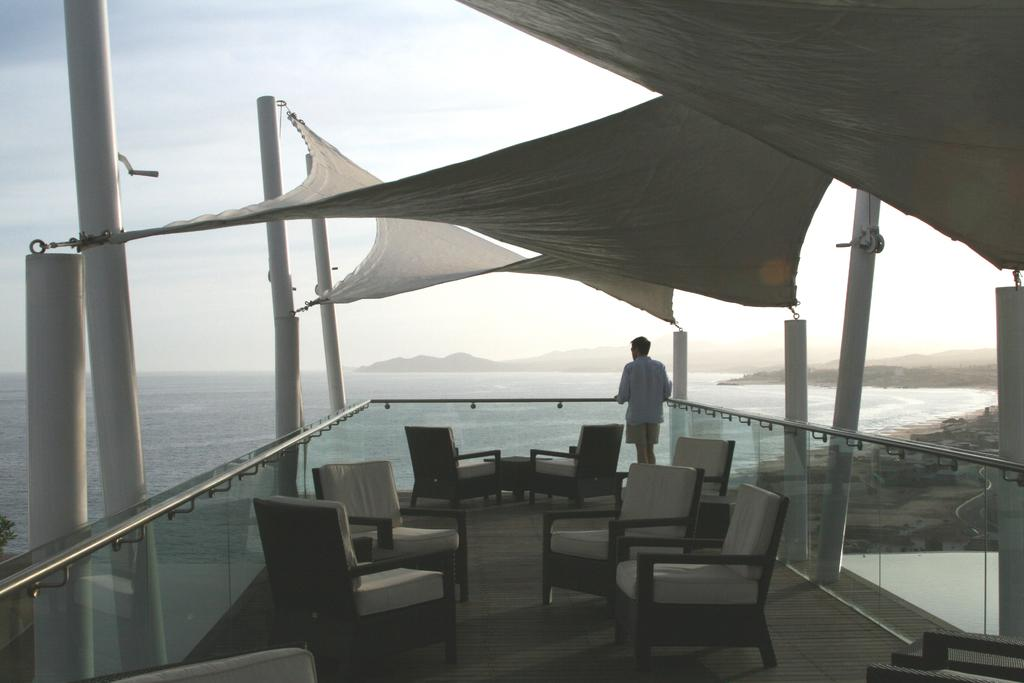What is the main subject of the image? The main subject of the image is a boat visible on a lake. What can be found inside the boat? The boat has chairs in it. What is the person in the image doing? There is a person standing in front of the fence of the boat. What can be seen in the background of the image? The sky is visible in the background of the image. What type of crack can be seen on the boat's hull in the image? There is no crack visible on the boat's hull in the image. Is there an umbrella being used by the person standing in front of the boat? There is no umbrella present in the image. 